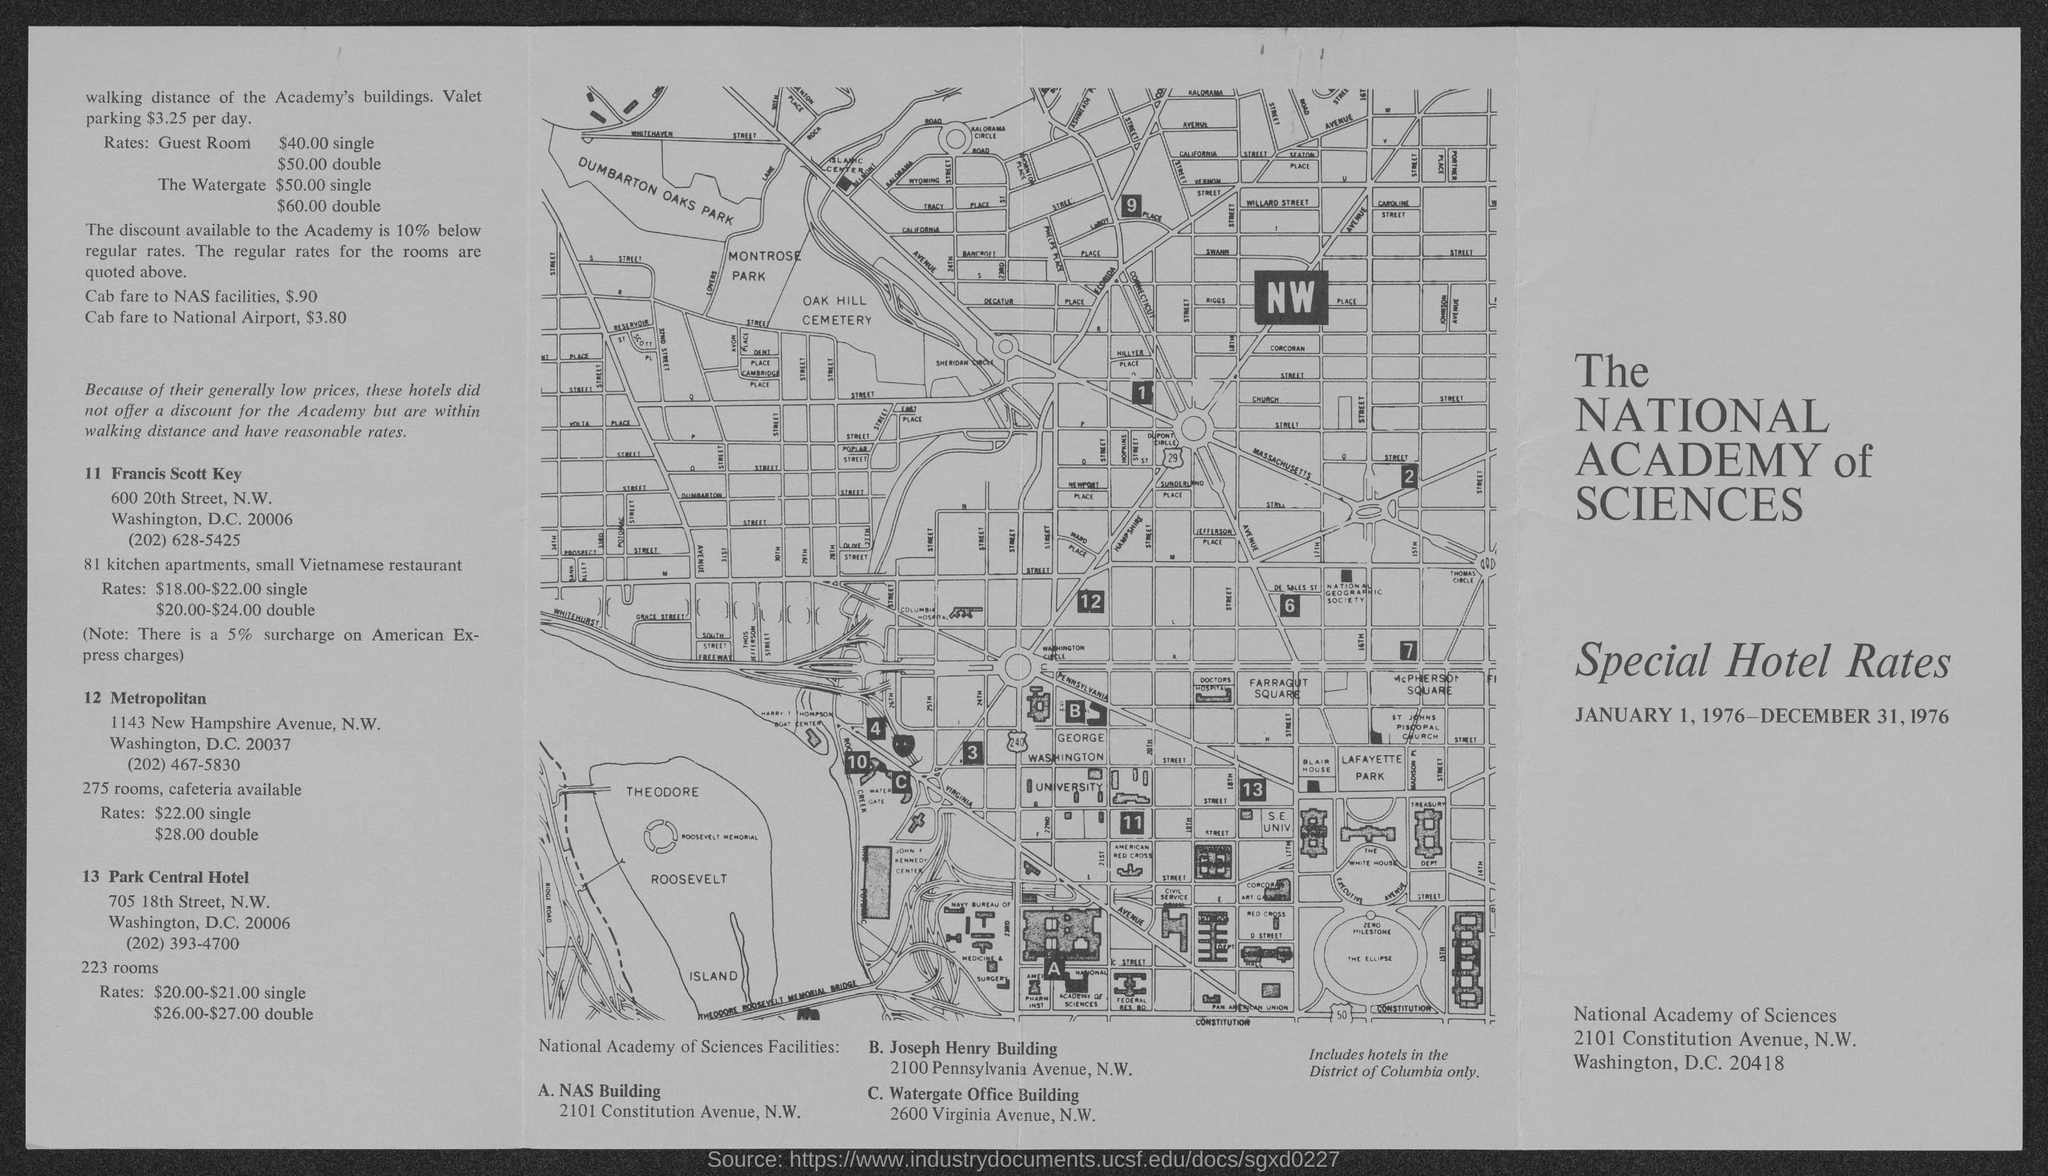What is the rate of the single guest room ?
Keep it short and to the point. $40.00. What is the rate of the water gate for single ?
Provide a succinct answer. $50.00. What is the rate of the water gate for double
Your answer should be very brief. $60.00. How much discount  is available to the academy below regular rates
Offer a terse response. The discount available to the Academy is 10% below regular rates. What is the cab fare to nas facilities ?
Provide a succinct answer. $ .90. What is the cab fare to national airport ?
Make the answer very short. $ 3.80. 